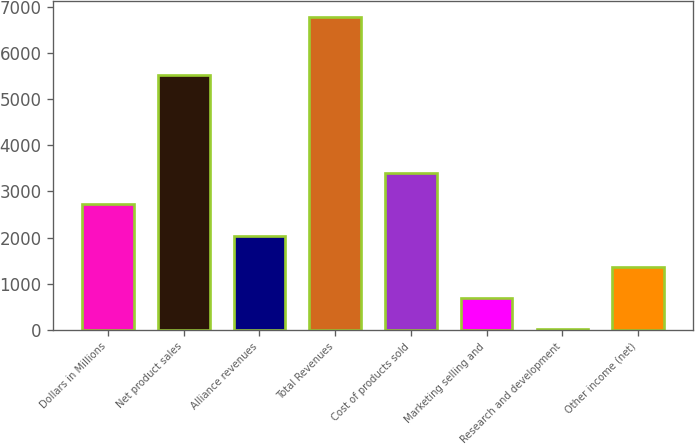Convert chart to OTSL. <chart><loc_0><loc_0><loc_500><loc_500><bar_chart><fcel>Dollars in Millions<fcel>Net product sales<fcel>Alliance revenues<fcel>Total Revenues<fcel>Cost of products sold<fcel>Marketing selling and<fcel>Research and development<fcel>Other income (net)<nl><fcel>2718.2<fcel>5530<fcel>2040.9<fcel>6782<fcel>3395.5<fcel>686.3<fcel>9<fcel>1363.6<nl></chart> 